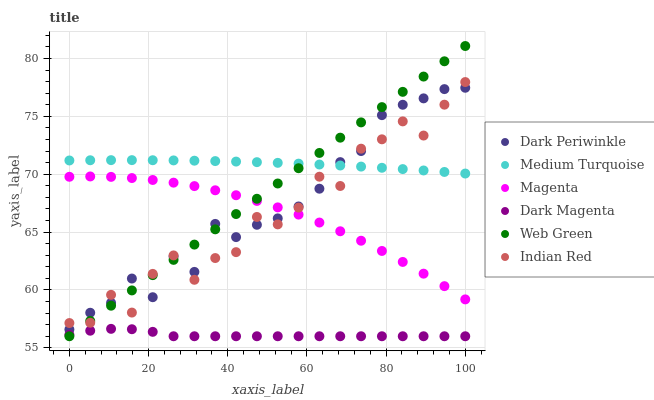Does Dark Magenta have the minimum area under the curve?
Answer yes or no. Yes. Does Medium Turquoise have the maximum area under the curve?
Answer yes or no. Yes. Does Web Green have the minimum area under the curve?
Answer yes or no. No. Does Web Green have the maximum area under the curve?
Answer yes or no. No. Is Web Green the smoothest?
Answer yes or no. Yes. Is Indian Red the roughest?
Answer yes or no. Yes. Is Indian Red the smoothest?
Answer yes or no. No. Is Web Green the roughest?
Answer yes or no. No. Does Web Green have the lowest value?
Answer yes or no. Yes. Does Indian Red have the lowest value?
Answer yes or no. No. Does Web Green have the highest value?
Answer yes or no. Yes. Does Indian Red have the highest value?
Answer yes or no. No. Is Dark Magenta less than Indian Red?
Answer yes or no. Yes. Is Indian Red greater than Dark Magenta?
Answer yes or no. Yes. Does Medium Turquoise intersect Web Green?
Answer yes or no. Yes. Is Medium Turquoise less than Web Green?
Answer yes or no. No. Is Medium Turquoise greater than Web Green?
Answer yes or no. No. Does Dark Magenta intersect Indian Red?
Answer yes or no. No. 